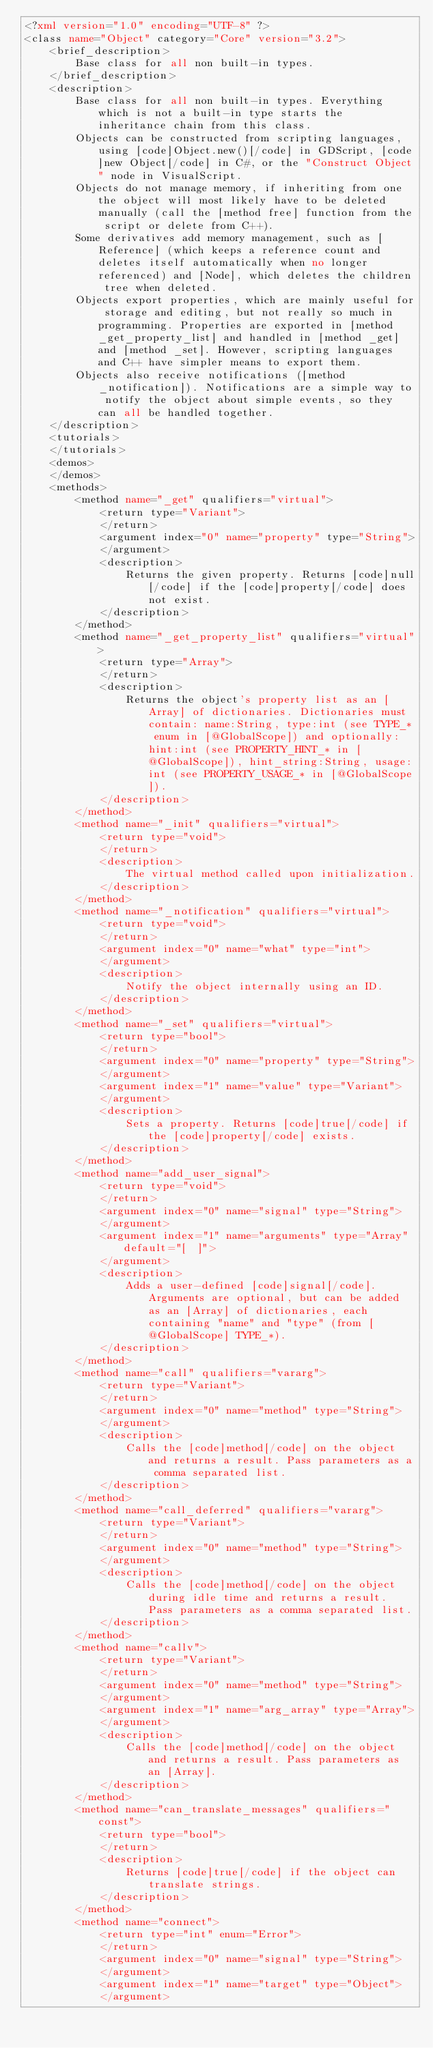<code> <loc_0><loc_0><loc_500><loc_500><_XML_><?xml version="1.0" encoding="UTF-8" ?>
<class name="Object" category="Core" version="3.2">
	<brief_description>
		Base class for all non built-in types.
	</brief_description>
	<description>
		Base class for all non built-in types. Everything which is not a built-in type starts the inheritance chain from this class.
		Objects can be constructed from scripting languages, using [code]Object.new()[/code] in GDScript, [code]new Object[/code] in C#, or the "Construct Object" node in VisualScript.
		Objects do not manage memory, if inheriting from one the object will most likely have to be deleted manually (call the [method free] function from the script or delete from C++).
		Some derivatives add memory management, such as [Reference] (which keeps a reference count and deletes itself automatically when no longer referenced) and [Node], which deletes the children tree when deleted.
		Objects export properties, which are mainly useful for storage and editing, but not really so much in programming. Properties are exported in [method _get_property_list] and handled in [method _get] and [method _set]. However, scripting languages and C++ have simpler means to export them.
		Objects also receive notifications ([method _notification]). Notifications are a simple way to notify the object about simple events, so they can all be handled together.
	</description>
	<tutorials>
	</tutorials>
	<demos>
	</demos>
	<methods>
		<method name="_get" qualifiers="virtual">
			<return type="Variant">
			</return>
			<argument index="0" name="property" type="String">
			</argument>
			<description>
				Returns the given property. Returns [code]null[/code] if the [code]property[/code] does not exist.
			</description>
		</method>
		<method name="_get_property_list" qualifiers="virtual">
			<return type="Array">
			</return>
			<description>
				Returns the object's property list as an [Array] of dictionaries. Dictionaries must contain: name:String, type:int (see TYPE_* enum in [@GlobalScope]) and optionally: hint:int (see PROPERTY_HINT_* in [@GlobalScope]), hint_string:String, usage:int (see PROPERTY_USAGE_* in [@GlobalScope]).
			</description>
		</method>
		<method name="_init" qualifiers="virtual">
			<return type="void">
			</return>
			<description>
				The virtual method called upon initialization.
			</description>
		</method>
		<method name="_notification" qualifiers="virtual">
			<return type="void">
			</return>
			<argument index="0" name="what" type="int">
			</argument>
			<description>
				Notify the object internally using an ID.
			</description>
		</method>
		<method name="_set" qualifiers="virtual">
			<return type="bool">
			</return>
			<argument index="0" name="property" type="String">
			</argument>
			<argument index="1" name="value" type="Variant">
			</argument>
			<description>
				Sets a property. Returns [code]true[/code] if the [code]property[/code] exists.
			</description>
		</method>
		<method name="add_user_signal">
			<return type="void">
			</return>
			<argument index="0" name="signal" type="String">
			</argument>
			<argument index="1" name="arguments" type="Array" default="[  ]">
			</argument>
			<description>
				Adds a user-defined [code]signal[/code]. Arguments are optional, but can be added as an [Array] of dictionaries, each containing "name" and "type" (from [@GlobalScope] TYPE_*).
			</description>
		</method>
		<method name="call" qualifiers="vararg">
			<return type="Variant">
			</return>
			<argument index="0" name="method" type="String">
			</argument>
			<description>
				Calls the [code]method[/code] on the object and returns a result. Pass parameters as a comma separated list.
			</description>
		</method>
		<method name="call_deferred" qualifiers="vararg">
			<return type="Variant">
			</return>
			<argument index="0" name="method" type="String">
			</argument>
			<description>
				Calls the [code]method[/code] on the object during idle time and returns a result. Pass parameters as a comma separated list.
			</description>
		</method>
		<method name="callv">
			<return type="Variant">
			</return>
			<argument index="0" name="method" type="String">
			</argument>
			<argument index="1" name="arg_array" type="Array">
			</argument>
			<description>
				Calls the [code]method[/code] on the object and returns a result. Pass parameters as an [Array].
			</description>
		</method>
		<method name="can_translate_messages" qualifiers="const">
			<return type="bool">
			</return>
			<description>
				Returns [code]true[/code] if the object can translate strings.
			</description>
		</method>
		<method name="connect">
			<return type="int" enum="Error">
			</return>
			<argument index="0" name="signal" type="String">
			</argument>
			<argument index="1" name="target" type="Object">
			</argument></code> 